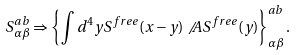Convert formula to latex. <formula><loc_0><loc_0><loc_500><loc_500>S ^ { a b } _ { \alpha \beta } \Rightarrow \left \{ \int d ^ { 4 } y S ^ { f r e e } ( x - y ) \not \, A S ^ { f r e e } ( y ) \right \} ^ { a b } _ { \alpha \beta } .</formula> 